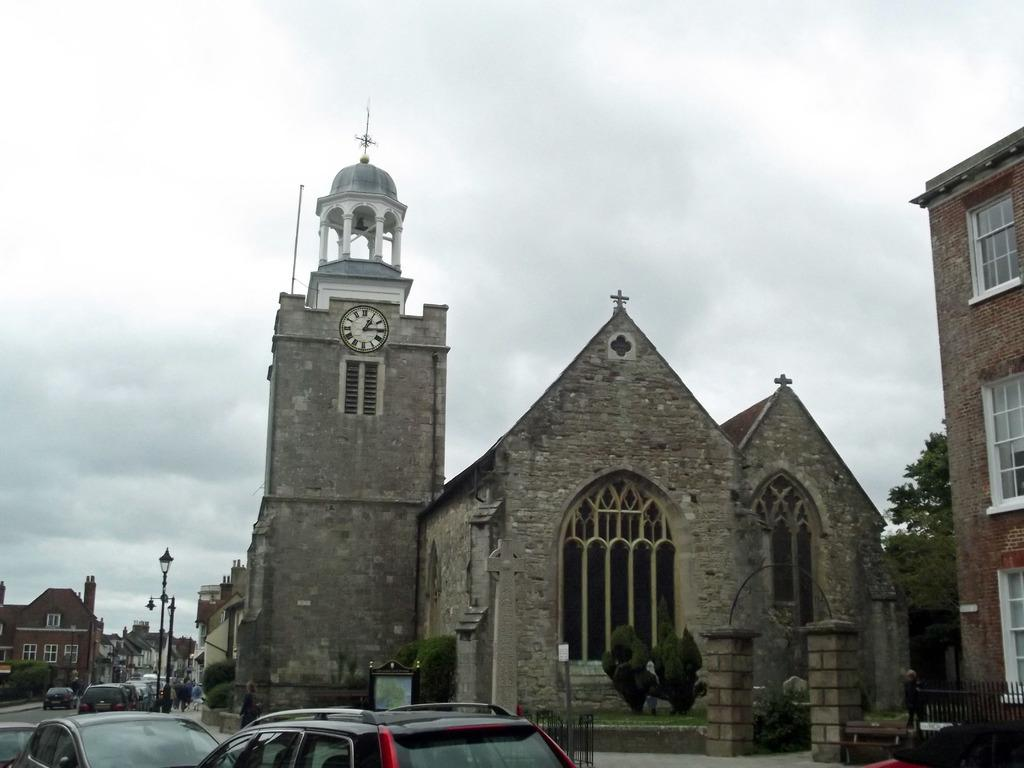What type of structures can be seen in the image? There are buildings in the image. Is there a specific type of building featured in the image? Yes, there is a clock tower in the image. What else can be seen on the ground in the image? There are vehicles on the road in the image. What are the light sources in the image? Light poles are visible in the image. How would you describe the sky in the image? The sky is visible in the image, with a color described as white and gray. How many chickens are running around in the image? There are no chickens present in the image. What type of debt is being discussed in the image? There is no mention of debt in the image. 